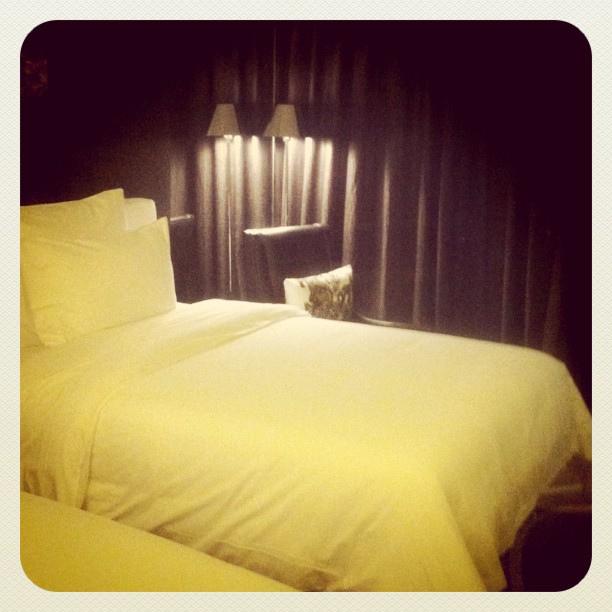Is this a hotel room?
Keep it brief. Yes. How many lights are against the curtain?
Quick response, please. 2. Is that bed comfy?
Quick response, please. Yes. 